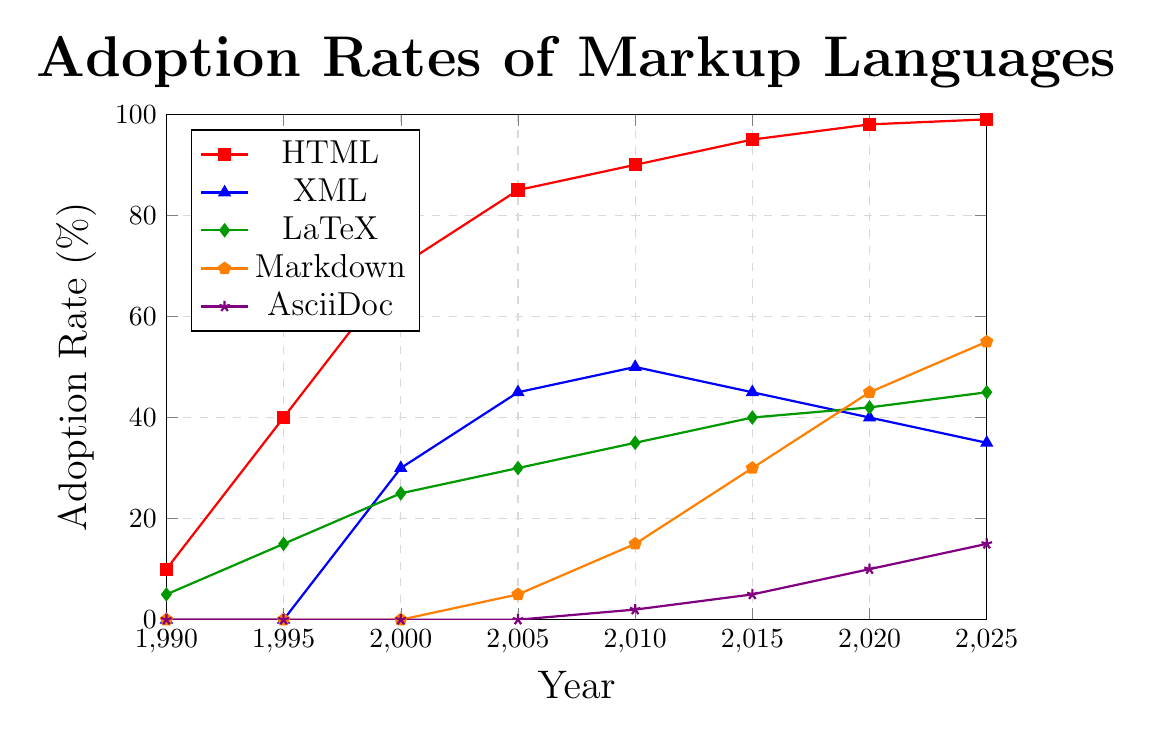What is the adoption rate of HTML in 2010? By looking at the plot, we can see that the adoption rate for HTML in 2010 reaches the value of the corresponding marker on the y-axis, which is 90%.
Answer: 90% At what year did Markdown start to see a notable increase in adoption rates? The adoption rate for Markdown started to increase notably around 2010 when its adoption reached 15%, showing significant growth from 0% in 2005.
Answer: 2010 Which markup language had the highest adoption rate in 2025? By comparing the heights of the lines at the year 2025, HTML has the highest adoption rate at 99%.
Answer: HTML Between which years did XML experience its peak adoption rate? Observing the chart, XML reached its peak adoption rate of 50% in the year 2010.
Answer: 2010 How does the adoption rate of LaTeX compare to that of AsciiDoc in 2020? Looking at the plot, in 2020, LaTeX has an adoption rate of 42% and AsciiDoc has an adoption rate of 10%. Therefore, LaTeX's adoption rate is higher than AsciiDoc's.
Answer: LaTeX is higher When did HTML surpass 50% adoption rate? HTML surpassed the 50% adoption rate between 1995 and 2000, reaching approximately 70% in 2000.
Answer: Between 1995 and 2000 What is the difference in adoption rates between Markdown and AsciiDoc in 2025? In 2025, the adoption rate of Markdown is 55% while that of AsciiDoc is 15%. The difference is calculated as 55% - 15% = 40%.
Answer: 40% By how much did the adoption rate of LaTeX increase between 1990 and 2025? LaTeX adoption was 5% in 1990 and increased to 45% in 2025. The difference is 45% - 5% = 40%.
Answer: 40% Which two markup languages show a decline in adoption rate from 2010 to 2025? From the plot, the lines for XML and HTML show a decline in adoption rates between 2010 and 2025, with XML going from 50% to 35% and HTML from 90% to 99%.
Answer: XML and HTML 